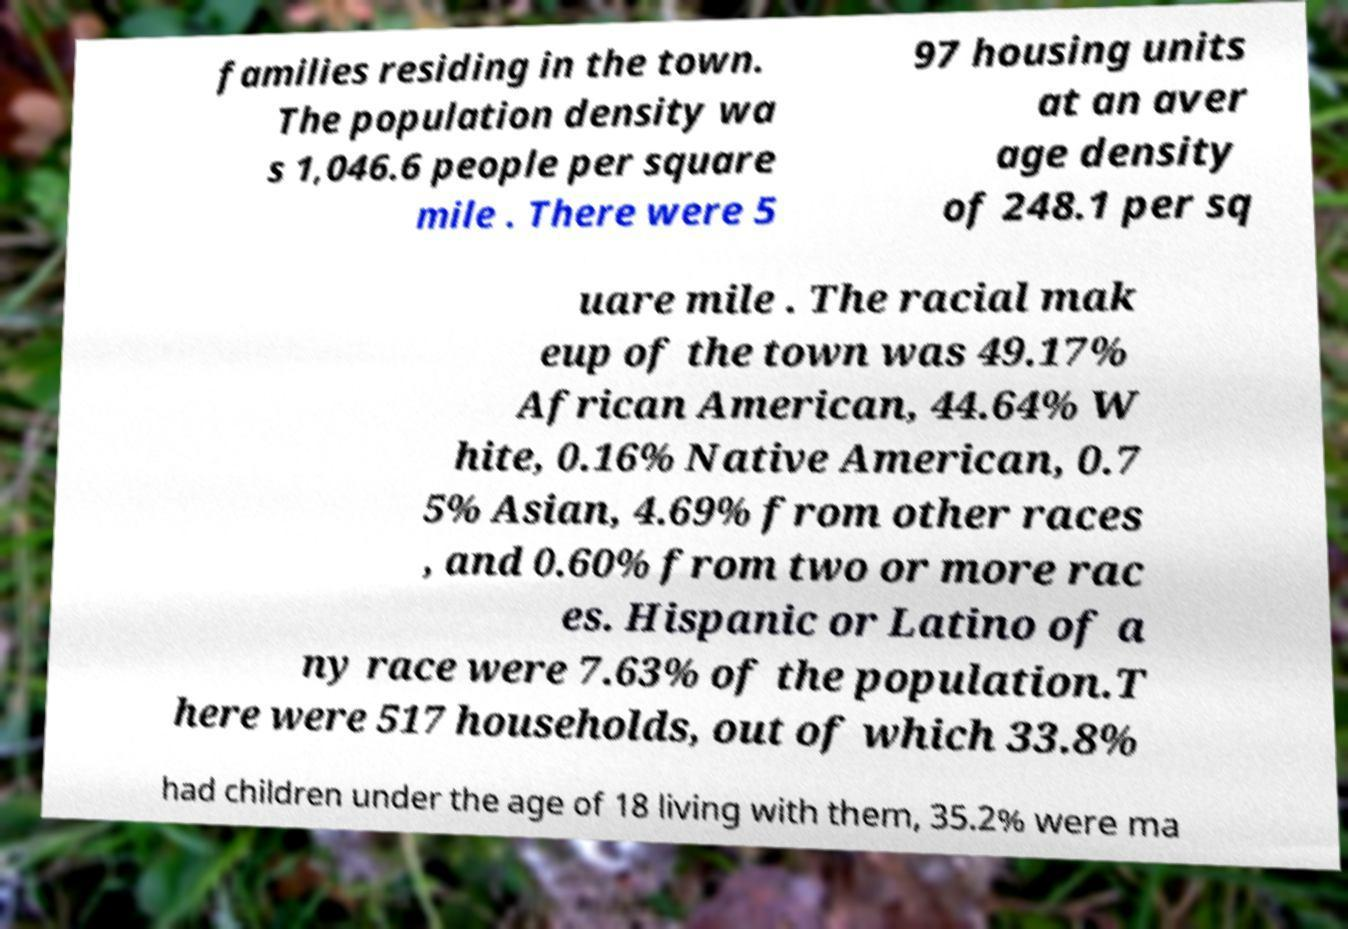Can you read and provide the text displayed in the image?This photo seems to have some interesting text. Can you extract and type it out for me? families residing in the town. The population density wa s 1,046.6 people per square mile . There were 5 97 housing units at an aver age density of 248.1 per sq uare mile . The racial mak eup of the town was 49.17% African American, 44.64% W hite, 0.16% Native American, 0.7 5% Asian, 4.69% from other races , and 0.60% from two or more rac es. Hispanic or Latino of a ny race were 7.63% of the population.T here were 517 households, out of which 33.8% had children under the age of 18 living with them, 35.2% were ma 